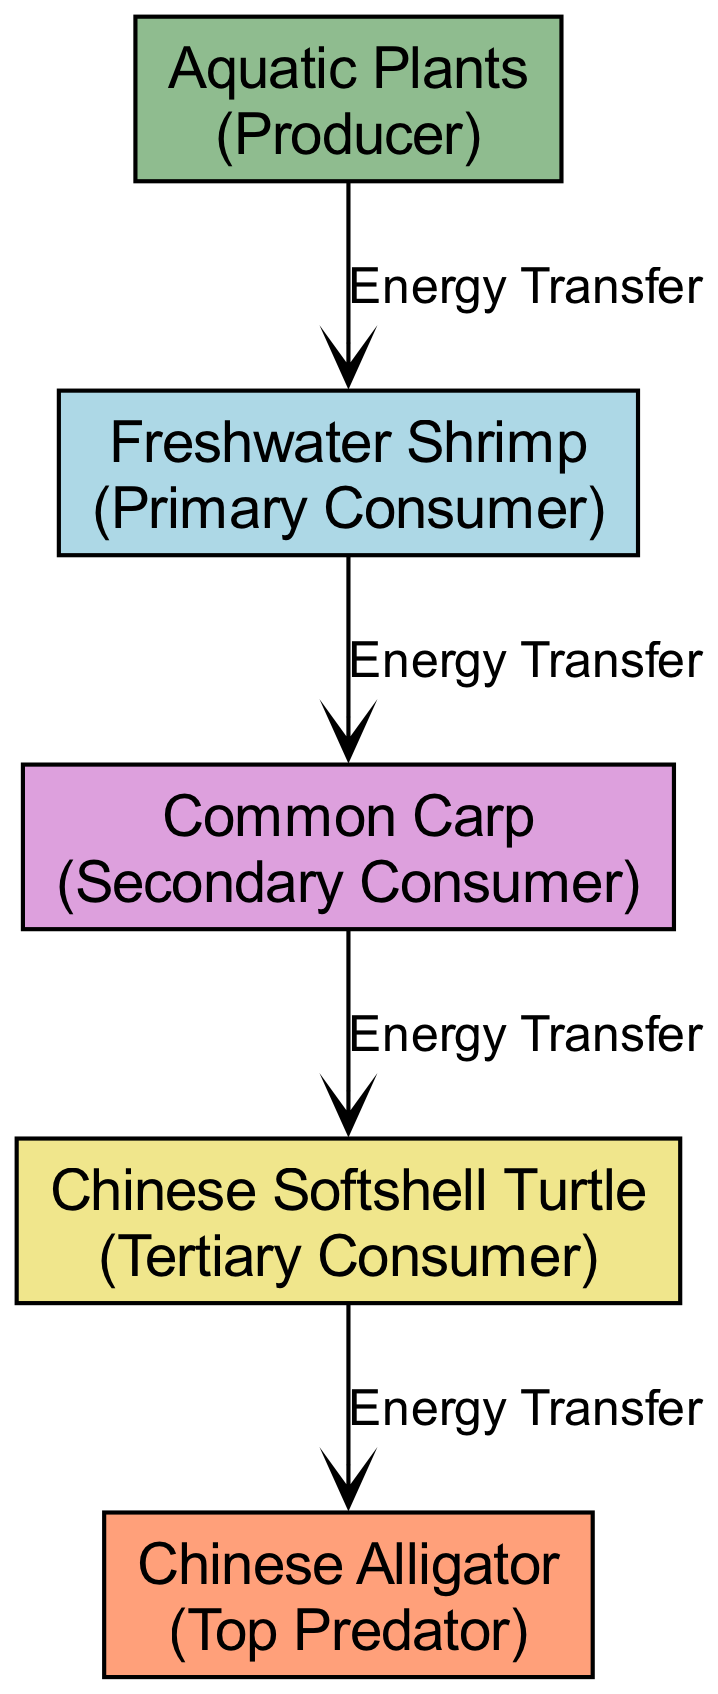What is the first trophic level in this food chain? The diagram indicates that "Aquatic Plants" are the first node and are categorized as a Producer. This establishes them as the primary source of energy in the ecosystem.
Answer: Aquatic Plants How many total nodes are present in the diagram? Counting each node listed in the data, we see five distinct nodes: Aquatic Plants, Freshwater Shrimp, Common Carp, Chinese Softshell Turtle, and Chinese Alligator. Thus, the total number of nodes is five.
Answer: 5 Which organism is at the highest trophic level? The highest trophic level is represented by the "Chinese Alligator," which is categorized as the Top Predator. This indicates that it has no natural predators within this food chain.
Answer: Chinese Alligator What is the relationship between Freshwater Shrimp and Common Carp? The diagram shows an edge labeled "Energy Transfer" connecting Freshwater Shrimp (a Primary Consumer) to Common Carp (a Secondary Consumer), indicating that energy is transferred from the Freshwater Shrimp to the Common Carp in this food chain.
Answer: Energy Transfer How many energy transfer edges are there in total? The diagram contains four edges representing the transfer of energy between the nodes: from Aquatic Plants to Freshwater Shrimp, from Freshwater Shrimp to Common Carp, from Common Carp to Chinese Softshell Turtle, and from Chinese Softshell Turtle to Chinese Alligator. Therefore, there are four energy transfer edges.
Answer: 4 What type of consumer is the Chinese Softshell Turtle? The diagram labels the Chinese Softshell Turtle as a Tertiary Consumer. This indicates its position within the ecosystem as one that consumes secondary consumers, indicating a higher energy level in the food chain compared to primary consumers.
Answer: Tertiary Consumer Who is the primary consumer in this ecosystem? The Freshwater Shrimp is listed as the primary consumer in the diagram, which shows that it primarily consumes the energy produced by Aquatic Plants. This categorization highlights its role as an intermediary in the energy flow from producers to higher consumers.
Answer: Freshwater Shrimp Which node serves as the producer in this food chain? The diagram distinctly identifies "Aquatic Plants" as the Producer. This classification is important as it signifies the starting point of the energy flow in the food chain, making it foundational for all other trophic levels.
Answer: Aquatic Plants 